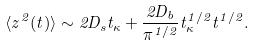Convert formula to latex. <formula><loc_0><loc_0><loc_500><loc_500>\langle z ^ { 2 } ( t ) \rangle \sim 2 D _ { s } t _ { \kappa } + \frac { 2 D _ { b } } { \pi ^ { 1 / 2 } } t _ { \kappa } ^ { 1 / 2 } t ^ { 1 / 2 } .</formula> 